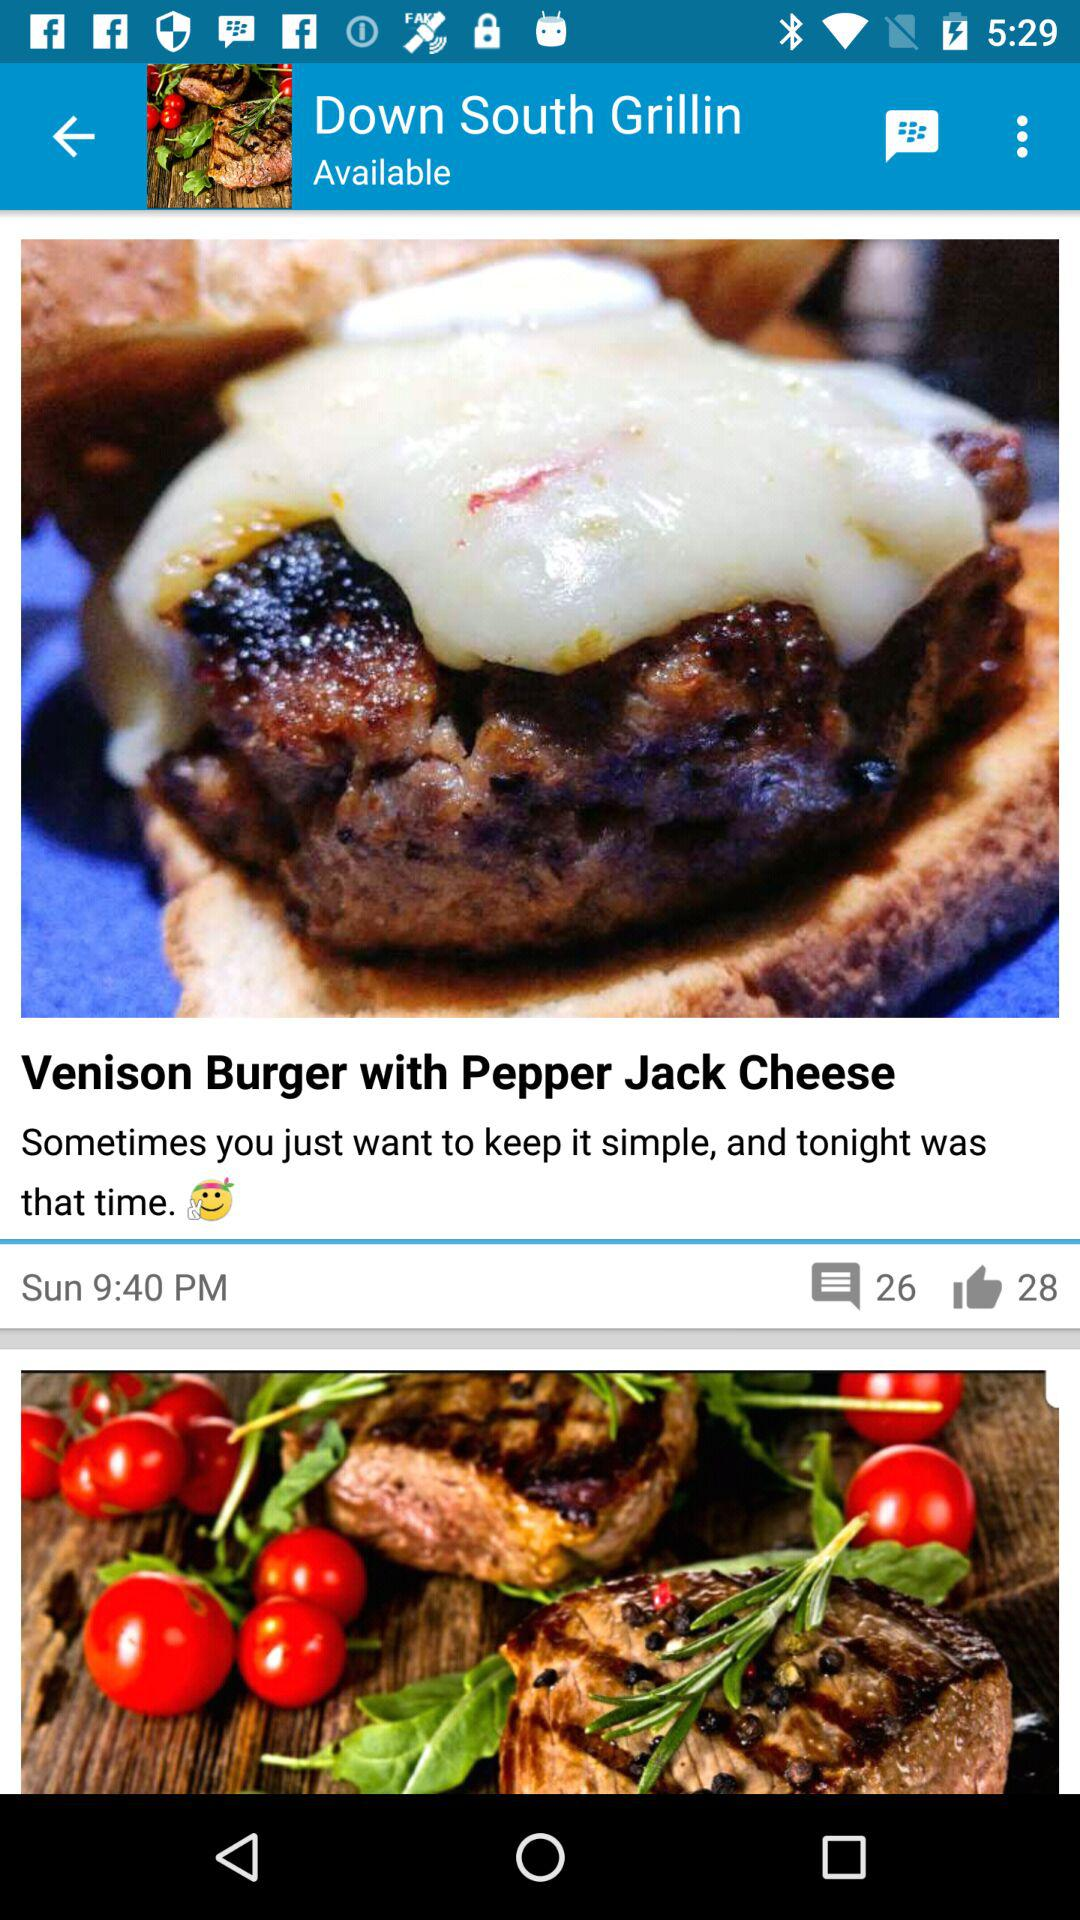How many comments are there for "Venison Burger with Pepper Jack Cheese"? There are 26 comments. 